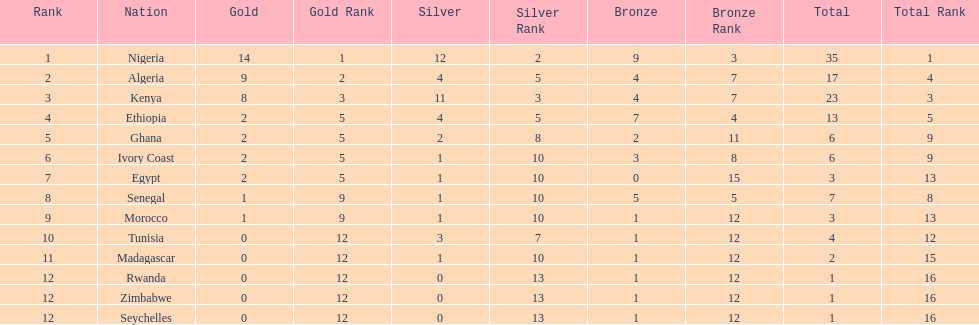What was the total number of medals the ivory coast won? 6. 